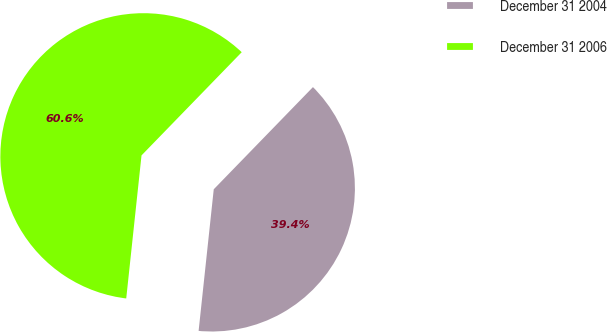Convert chart. <chart><loc_0><loc_0><loc_500><loc_500><pie_chart><fcel>December 31 2004<fcel>December 31 2006<nl><fcel>39.43%<fcel>60.57%<nl></chart> 